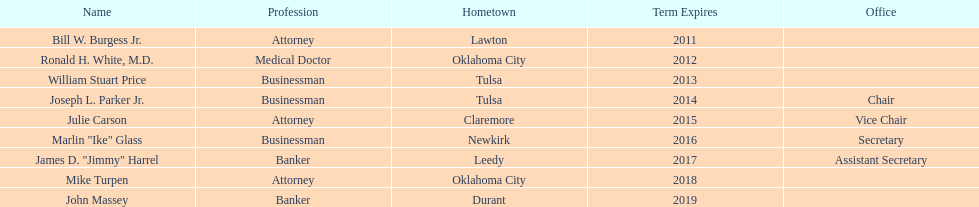What is the number of members who have listed "businessman" as their occupation? 3. 